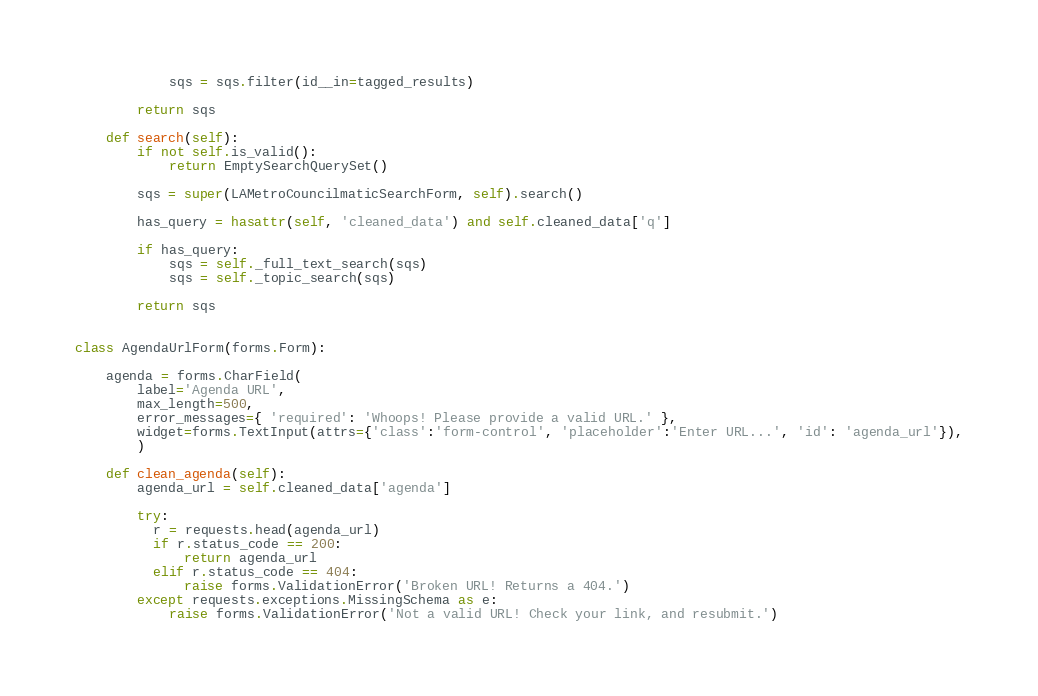Convert code to text. <code><loc_0><loc_0><loc_500><loc_500><_Python_>            sqs = sqs.filter(id__in=tagged_results)

        return sqs

    def search(self):
        if not self.is_valid():
            return EmptySearchQuerySet()

        sqs = super(LAMetroCouncilmaticSearchForm, self).search()

        has_query = hasattr(self, 'cleaned_data') and self.cleaned_data['q']

        if has_query:
            sqs = self._full_text_search(sqs)
            sqs = self._topic_search(sqs)

        return sqs


class AgendaUrlForm(forms.Form):

    agenda = forms.CharField(
        label='Agenda URL',
        max_length=500,
        error_messages={ 'required': 'Whoops! Please provide a valid URL.' },
        widget=forms.TextInput(attrs={'class':'form-control', 'placeholder':'Enter URL...', 'id': 'agenda_url'}),
        )

    def clean_agenda(self):
        agenda_url = self.cleaned_data['agenda']

        try:
          r = requests.head(agenda_url)
          if r.status_code == 200:
              return agenda_url
          elif r.status_code == 404:
              raise forms.ValidationError('Broken URL! Returns a 404.')
        except requests.exceptions.MissingSchema as e:
            raise forms.ValidationError('Not a valid URL! Check your link, and resubmit.')

</code> 